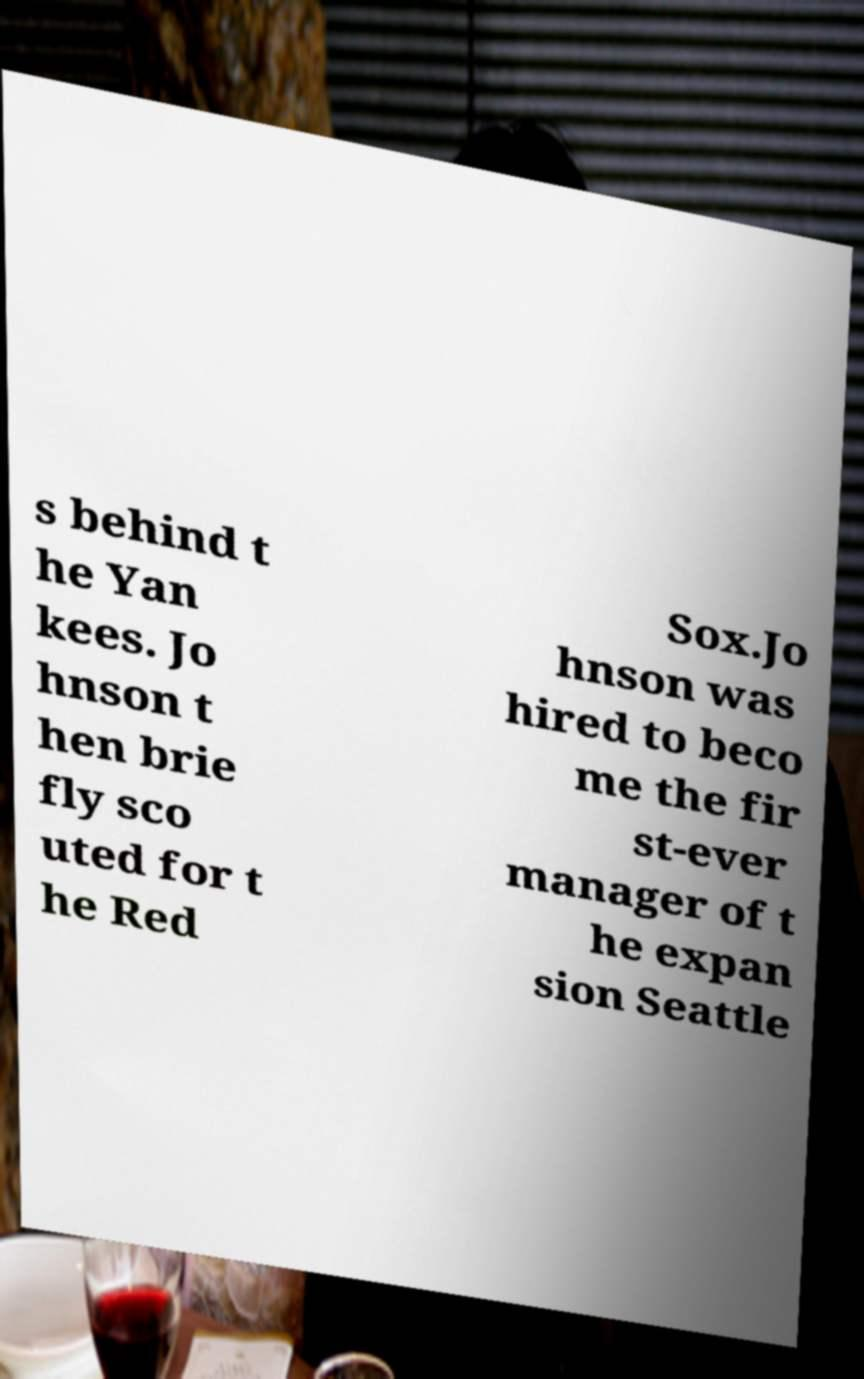Could you extract and type out the text from this image? s behind t he Yan kees. Jo hnson t hen brie fly sco uted for t he Red Sox.Jo hnson was hired to beco me the fir st-ever manager of t he expan sion Seattle 